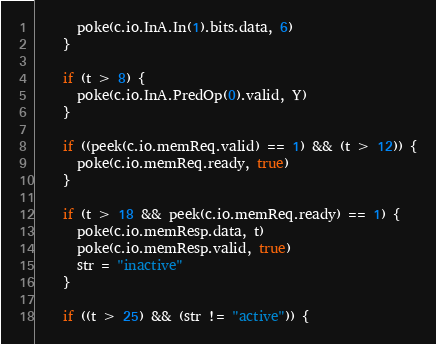<code> <loc_0><loc_0><loc_500><loc_500><_Scala_>      poke(c.io.InA.In(1).bits.data, 6)
    }

    if (t > 8) {
      poke(c.io.InA.PredOp(0).valid, Y)
    }

    if ((peek(c.io.memReq.valid) == 1) && (t > 12)) {
      poke(c.io.memReq.ready, true)
    }

    if (t > 18 && peek(c.io.memReq.ready) == 1) {
      poke(c.io.memResp.data, t)
      poke(c.io.memResp.valid, true)
      str = "inactive"
    }

    if ((t > 25) && (str != "active")) {</code> 